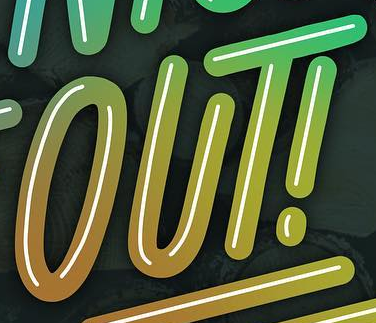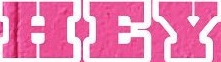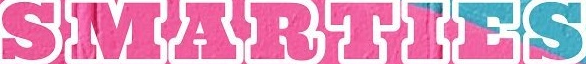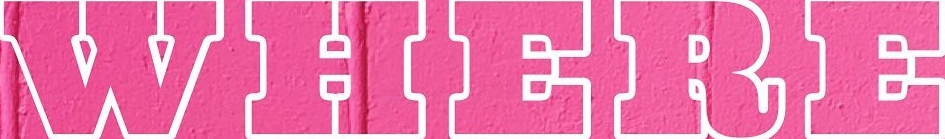What words can you see in these images in sequence, separated by a semicolon? OUT!; HEY; SMARTIES; WHERE 